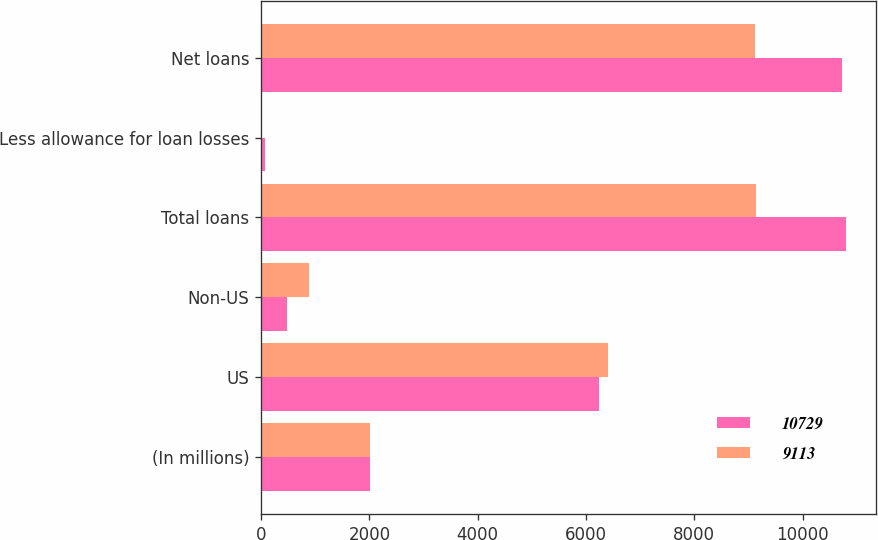Convert chart. <chart><loc_0><loc_0><loc_500><loc_500><stacked_bar_chart><ecel><fcel>(In millions)<fcel>US<fcel>Non-US<fcel>Total loans<fcel>Less allowance for loan losses<fcel>Net loans<nl><fcel>10729<fcel>2009<fcel>6239<fcel>471<fcel>10808<fcel>79<fcel>10729<nl><fcel>9113<fcel>2008<fcel>6397<fcel>890<fcel>9131<fcel>18<fcel>9113<nl></chart> 